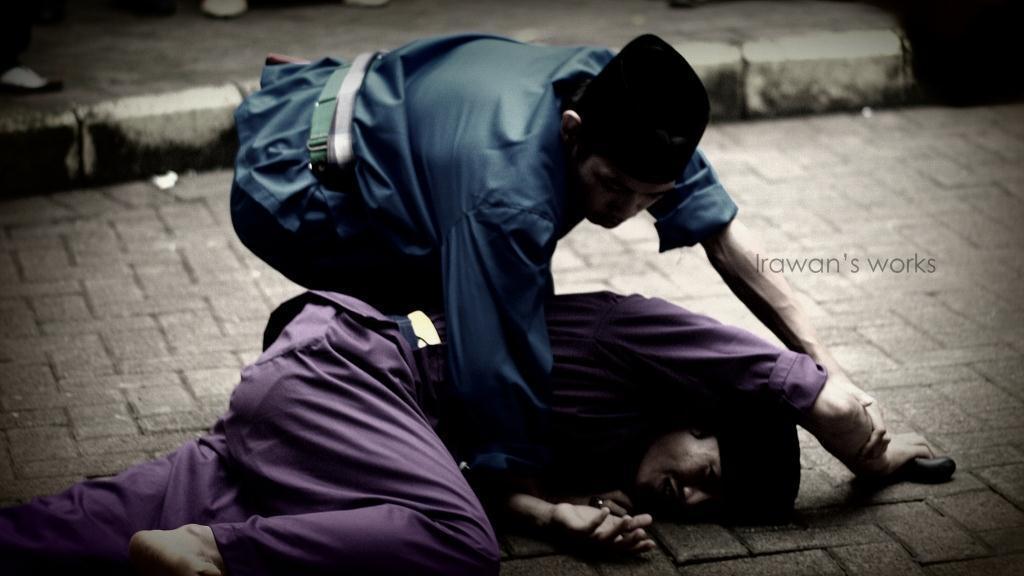In one or two sentences, can you explain what this image depicts? At the bottom of the image, we can see a person is lying on the path. Here a person is holding the other person. On the right side of the image, there is a watermark. At the top of the image, it looks like a few people are there on the walkway. 